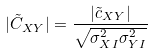Convert formula to latex. <formula><loc_0><loc_0><loc_500><loc_500>| \tilde { C } _ { X Y } | = \frac { | \tilde { c } _ { X Y } | } { \sqrt { \sigma ^ { 2 } _ { X I } \sigma ^ { 2 } _ { Y I } } }</formula> 